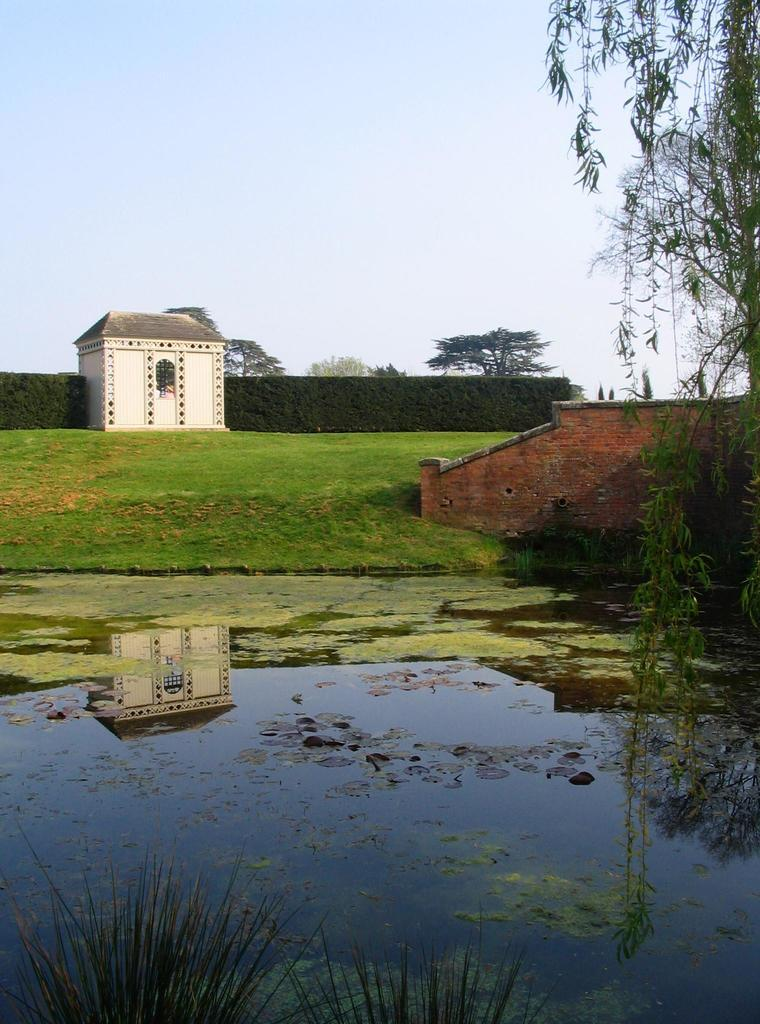What can be seen in the sky in the image? The sky is visible in the image. What type of vegetation is present in the image? Creepers, trees, and bushes are visible in the image. What type of structure is in the image? There is a building in the image. Is there any water visible in the image? Yes, groundwater is present in the image. What is floating on the water in the image? Duckweed is on the water in the image. Where is the curtain located in the image? There is no curtain present in the image. Can you see a bee flying around the trees in the image? There is no bee visible in the image. 